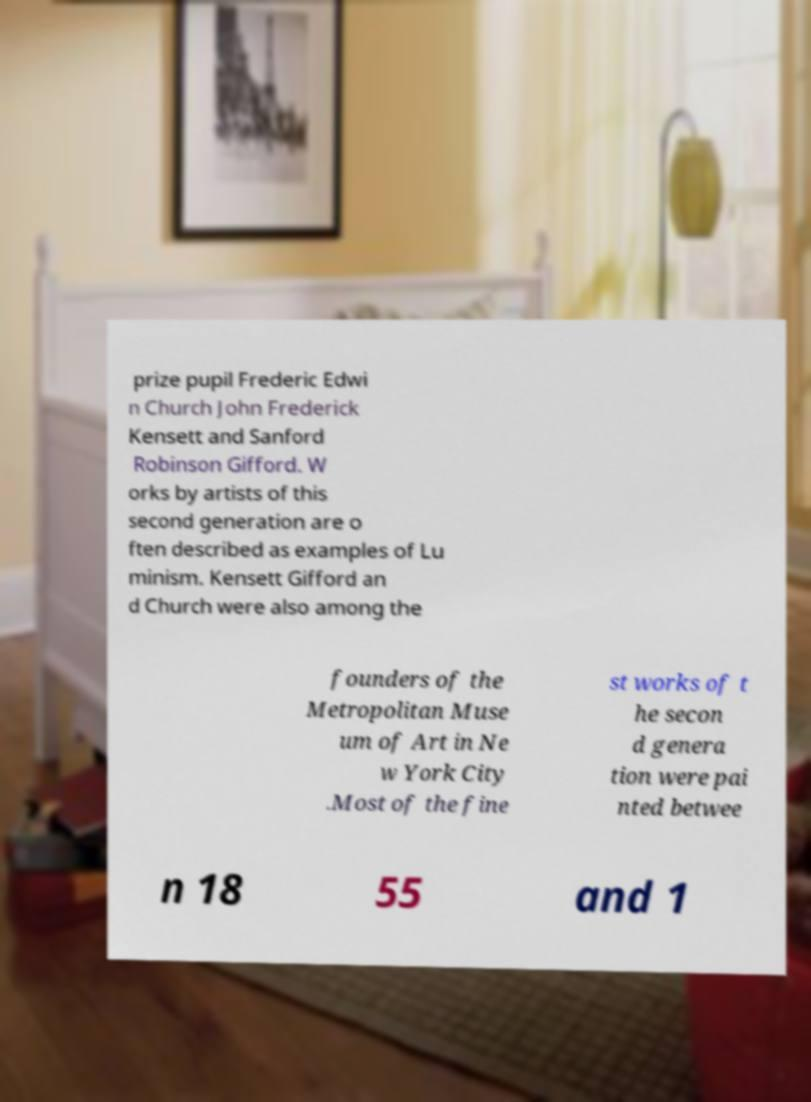Please identify and transcribe the text found in this image. prize pupil Frederic Edwi n Church John Frederick Kensett and Sanford Robinson Gifford. W orks by artists of this second generation are o ften described as examples of Lu minism. Kensett Gifford an d Church were also among the founders of the Metropolitan Muse um of Art in Ne w York City .Most of the fine st works of t he secon d genera tion were pai nted betwee n 18 55 and 1 